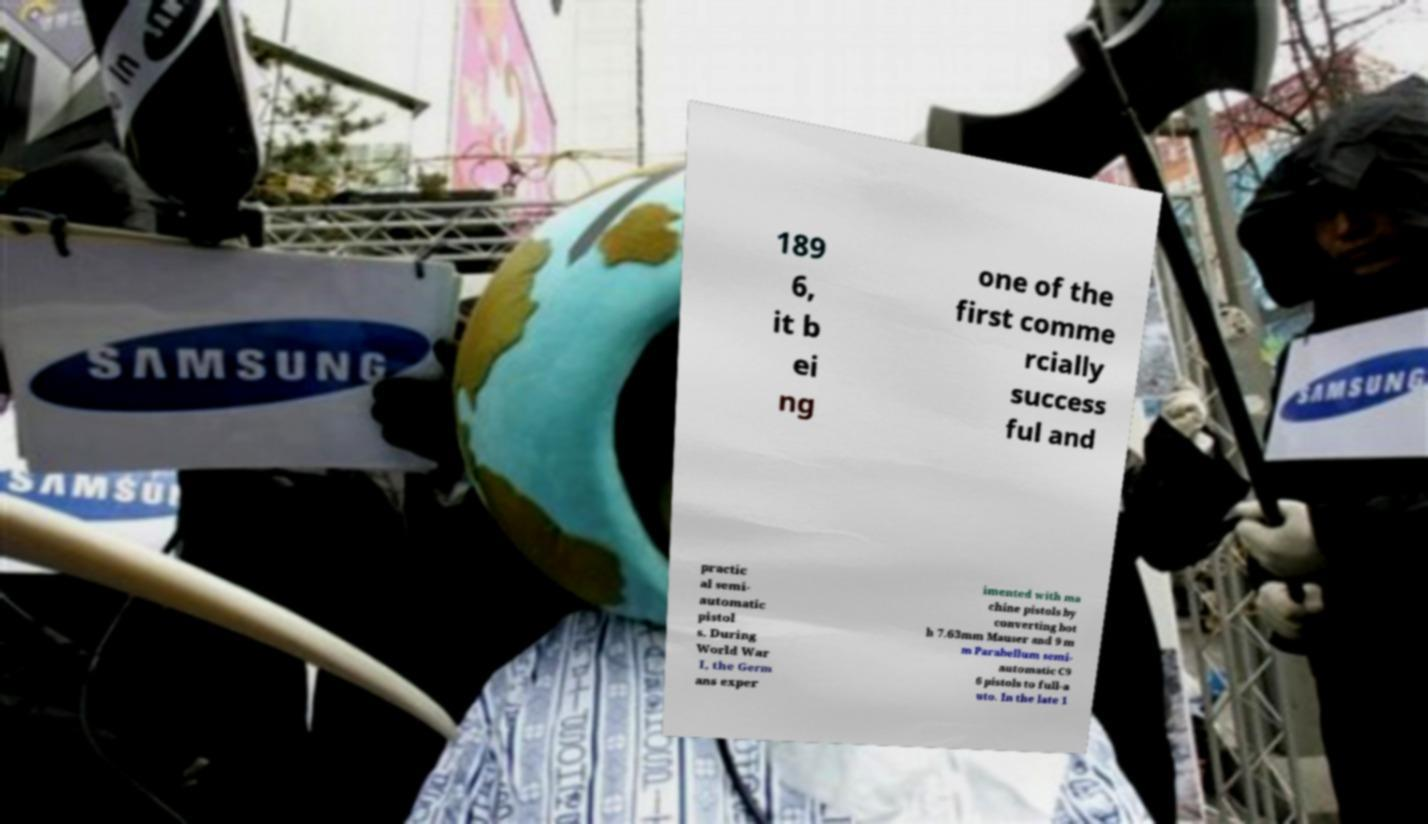Could you extract and type out the text from this image? 189 6, it b ei ng one of the first comme rcially success ful and practic al semi- automatic pistol s. During World War I, the Germ ans exper imented with ma chine pistols by converting bot h 7.63mm Mauser and 9 m m Parabellum semi- automatic C9 6 pistols to full-a uto. In the late 1 